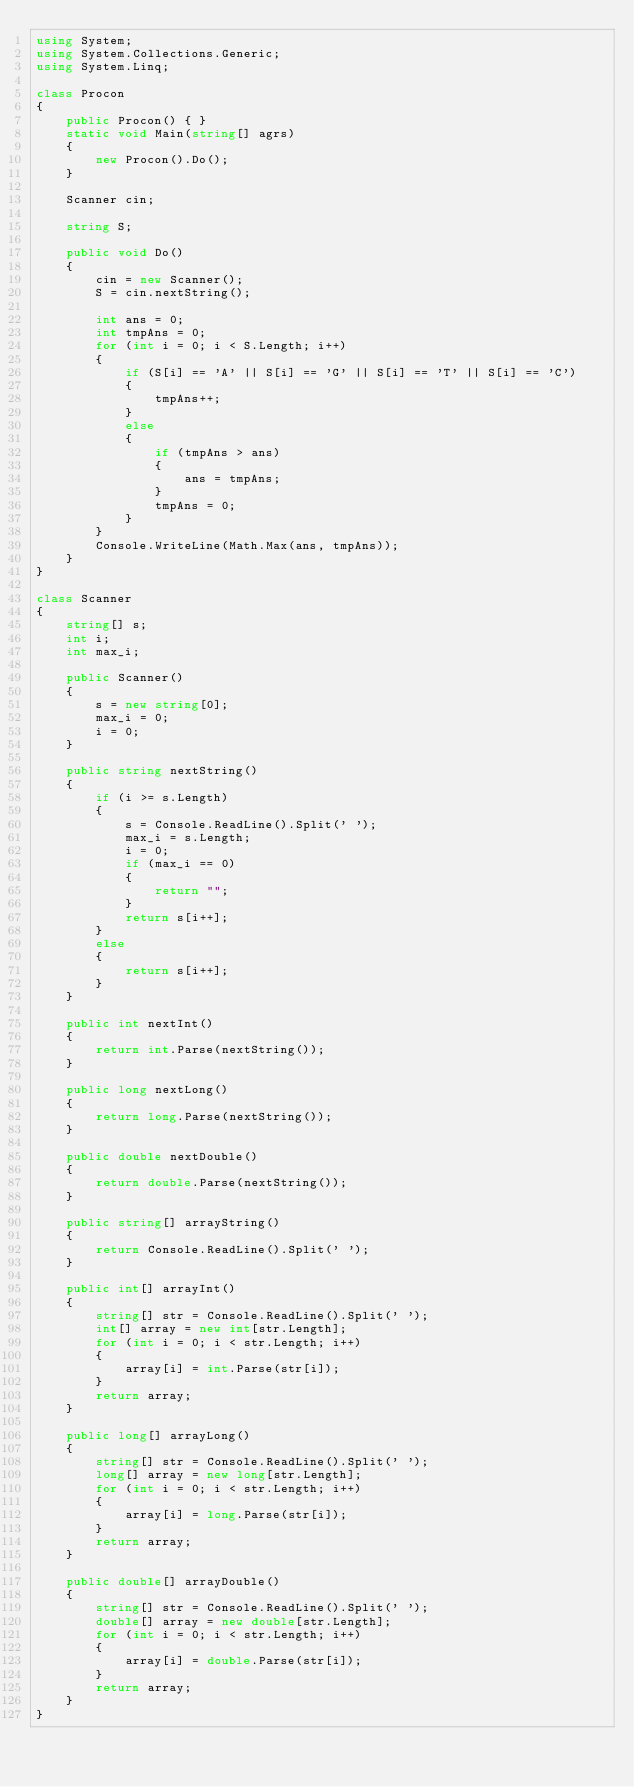Convert code to text. <code><loc_0><loc_0><loc_500><loc_500><_C#_>using System;
using System.Collections.Generic;
using System.Linq;

class Procon
{
    public Procon() { }
    static void Main(string[] agrs)
    {
        new Procon().Do();
    }

    Scanner cin;

    string S;

    public void Do()
    {
        cin = new Scanner();
        S = cin.nextString();

        int ans = 0;
        int tmpAns = 0;
        for (int i = 0; i < S.Length; i++)
        {
            if (S[i] == 'A' || S[i] == 'G' || S[i] == 'T' || S[i] == 'C')
            {
                tmpAns++;
            }
            else
            {
                if (tmpAns > ans)
                {
                    ans = tmpAns;
                }
                tmpAns = 0;
            }
        }
        Console.WriteLine(Math.Max(ans, tmpAns));
    }
}

class Scanner
{
    string[] s;
    int i;
    int max_i;

    public Scanner()
    {
        s = new string[0];
        max_i = 0;
        i = 0;
    }

    public string nextString()
    {
        if (i >= s.Length)
        {
            s = Console.ReadLine().Split(' ');
            max_i = s.Length;
            i = 0;
            if (max_i == 0)
            {
                return "";
            }
            return s[i++];
        }
        else
        {
            return s[i++];
        }
    }

    public int nextInt()
    {
        return int.Parse(nextString());
    }

    public long nextLong()
    {
        return long.Parse(nextString());
    }

    public double nextDouble()
    {
        return double.Parse(nextString());
    }

    public string[] arrayString()
    {
        return Console.ReadLine().Split(' ');
    }

    public int[] arrayInt()
    {
        string[] str = Console.ReadLine().Split(' ');
        int[] array = new int[str.Length];
        for (int i = 0; i < str.Length; i++)
        {
            array[i] = int.Parse(str[i]);
        }
        return array;
    }

    public long[] arrayLong()
    {
        string[] str = Console.ReadLine().Split(' ');
        long[] array = new long[str.Length];
        for (int i = 0; i < str.Length; i++)
        {
            array[i] = long.Parse(str[i]);
        }
        return array;
    }

    public double[] arrayDouble()
    {
        string[] str = Console.ReadLine().Split(' ');
        double[] array = new double[str.Length];
        for (int i = 0; i < str.Length; i++)
        {
            array[i] = double.Parse(str[i]);
        }
        return array;
    }
}</code> 